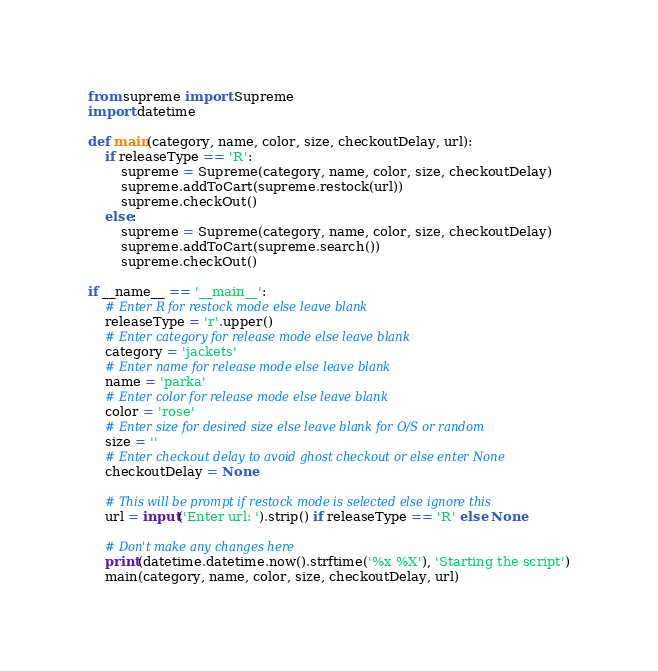Convert code to text. <code><loc_0><loc_0><loc_500><loc_500><_Python_>from supreme import Supreme
import datetime

def main(category, name, color, size, checkoutDelay, url):
    if releaseType == 'R':
        supreme = Supreme(category, name, color, size, checkoutDelay)
        supreme.addToCart(supreme.restock(url))
        supreme.checkOut()
    else:
        supreme = Supreme(category, name, color, size, checkoutDelay)
        supreme.addToCart(supreme.search())
        supreme.checkOut()

if __name__ == '__main__':
    # Enter R for restock mode else leave blank
    releaseType = 'r'.upper()
    # Enter category for release mode else leave blank
    category = 'jackets'
    # Enter name for release mode else leave blank
    name = 'parka'
    # Enter color for release mode else leave blank
    color = 'rose'
    # Enter size for desired size else leave blank for O/S or random
    size = ''
    # Enter checkout delay to avoid ghost checkout or else enter None
    checkoutDelay = None

    # This will be prompt if restock mode is selected else ignore this
    url = input('Enter url: ').strip() if releaseType == 'R' else None

    # Don't make any changes here
    print(datetime.datetime.now().strftime('%x %X'), 'Starting the script')
    main(category, name, color, size, checkoutDelay, url) 
</code> 